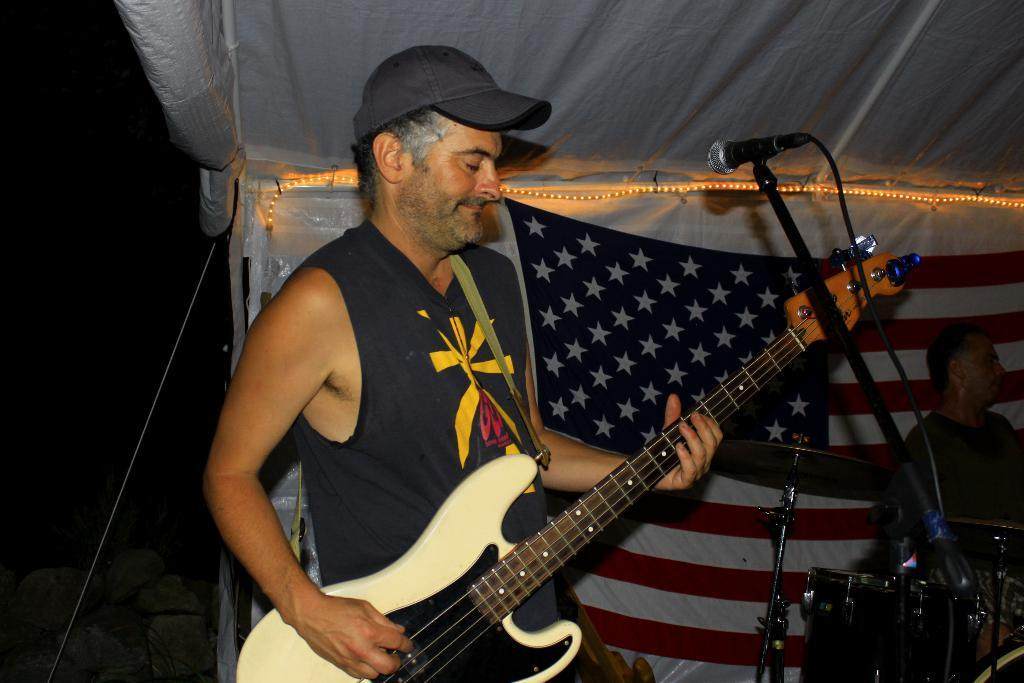What is the man in the image holding? The man is holding a guitar. What is the man in the image doing with the guitar? The man is in front of a microphone, which suggests he might be singing or performing. What can be seen in the background of the image? There is a flag in the background of the image. Are there any other people in the image? Yes, there is a man with a musical instrument in the background of the image. What type of furniture is visible in the image? There is no furniture visible in the image. What is the purpose of the clocks in the image? There are no clocks present in the image. 